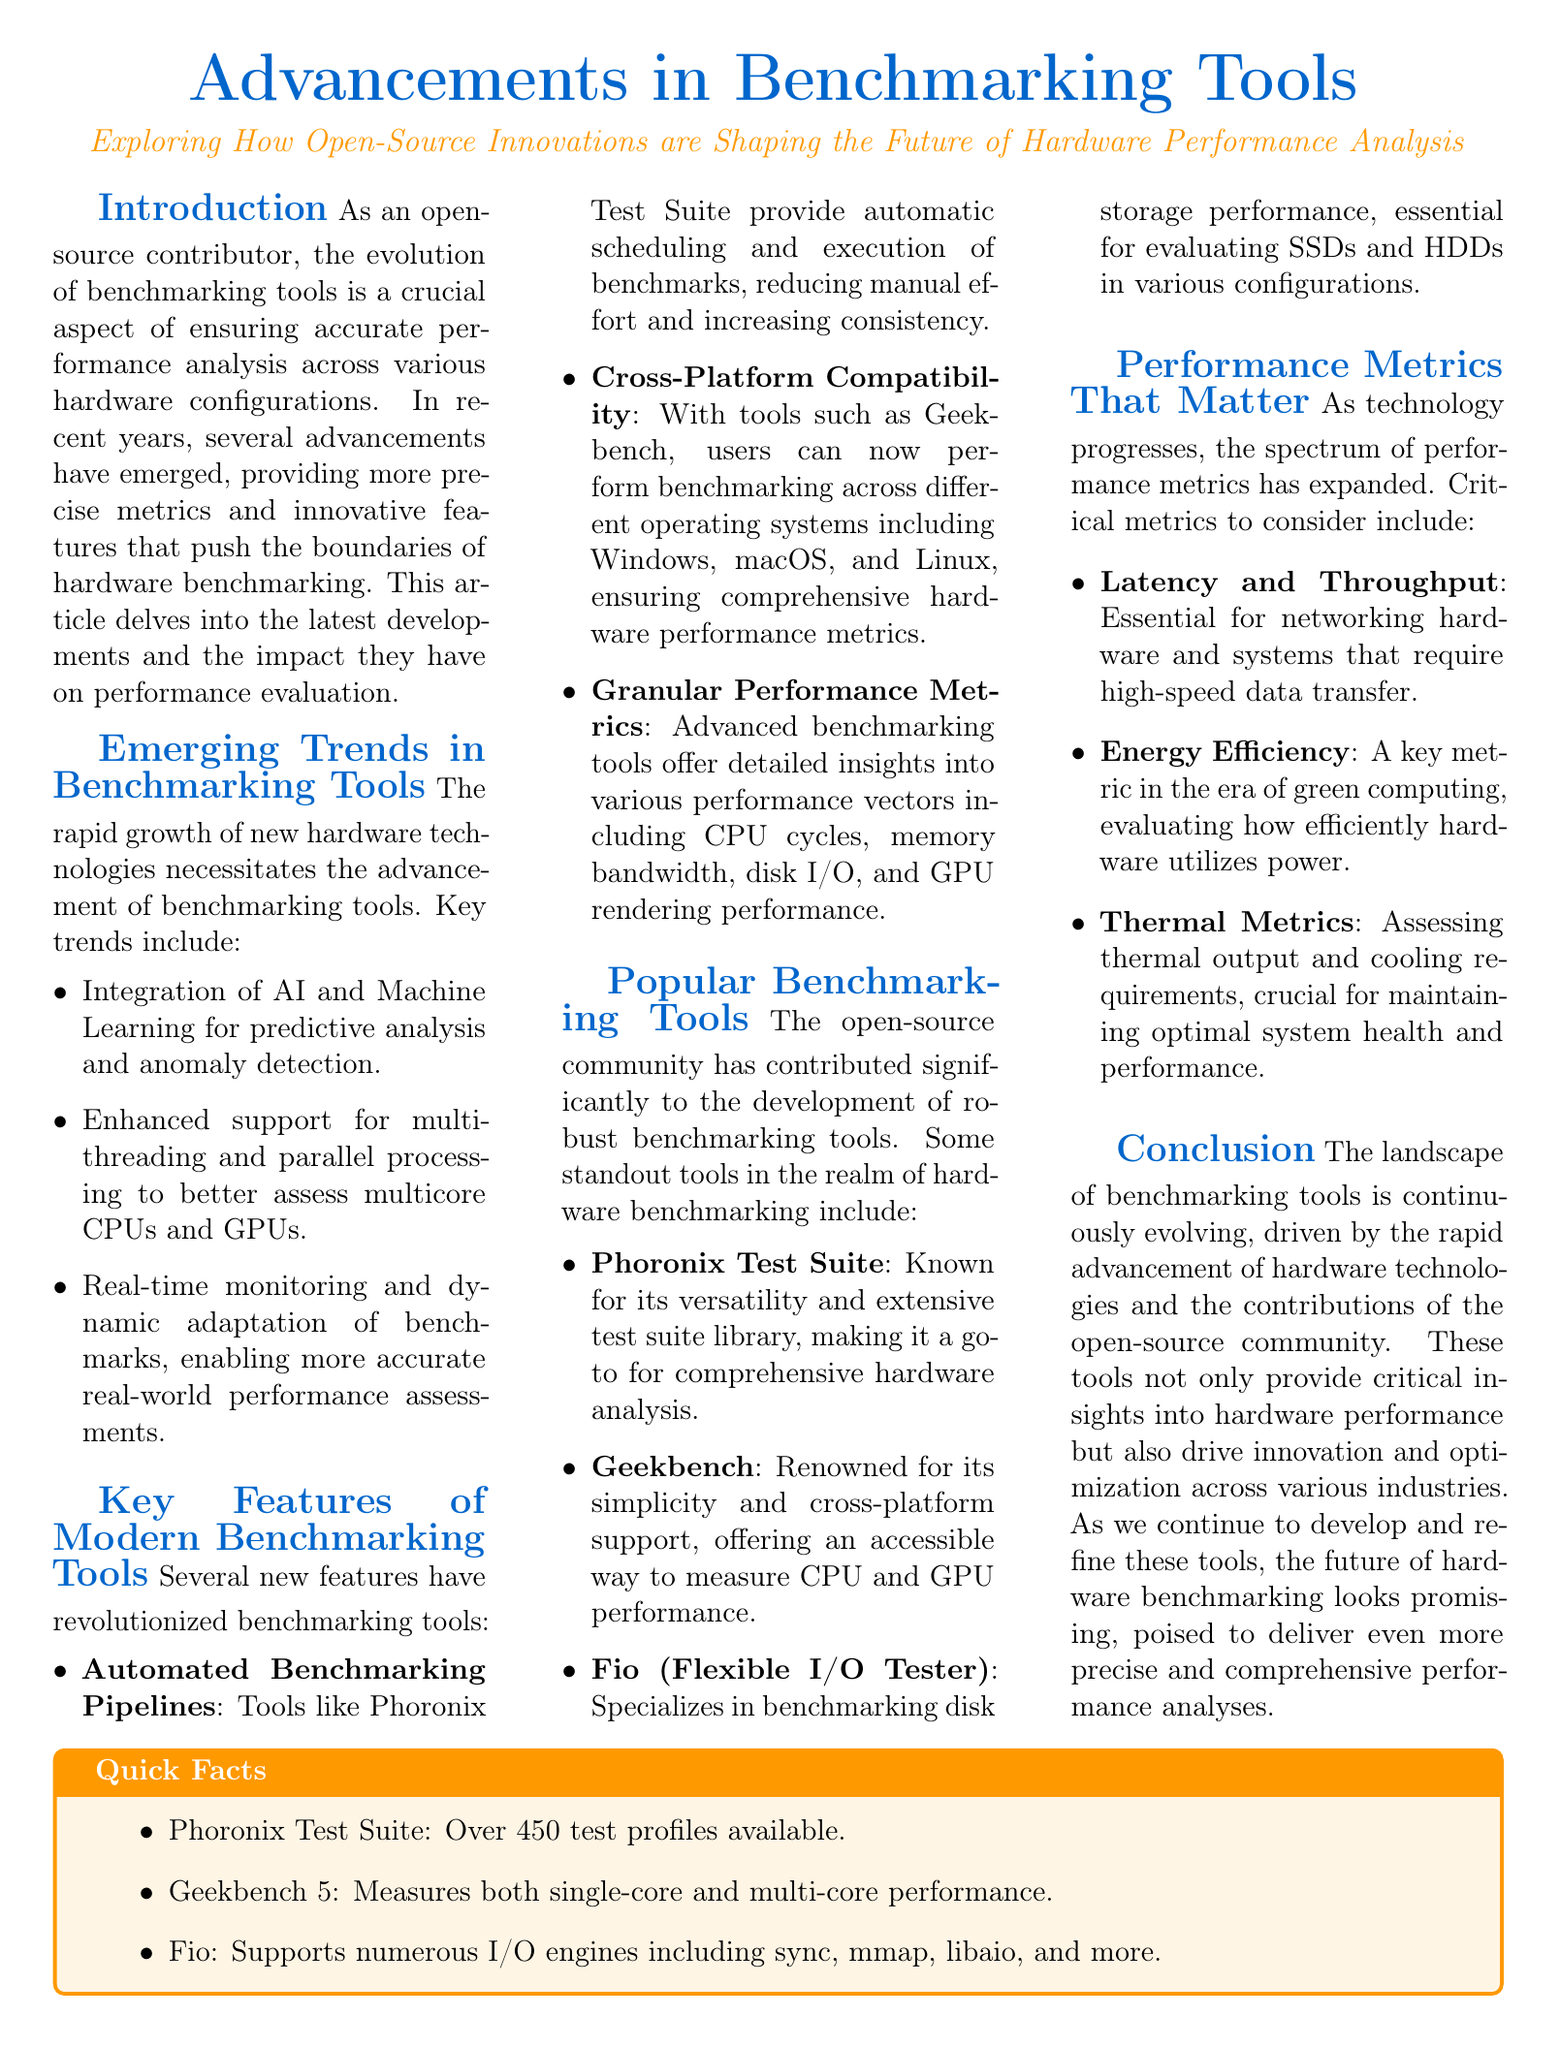What is the title of the article? The title is prominently displayed at the top of the document and indicates the primary focus of the content.
Answer: Advancements in Benchmarking Tools What type of innovations are shaping the future of hardware performance analysis? The subtitle suggests a specific focus on the impact of community contributions in the evolution of benchmarking tools.
Answer: Open-Source Innovations Name a tool known for its versatility and extensive test suite library. Within the section dedicated to popular benchmarking tools, one tool is specifically highlighted for its capabilities.
Answer: Phoronix Test Suite What metric is crucial for maintaining optimal system health? The document lists key performance metrics, one of which pertains to system performance and health.
Answer: Thermal Metrics How many test profiles are available in the Phoronix Test Suite? This detail is mentioned in the Quick Facts box, summarizing notable features of the discussed tools.
Answer: Over 450 test profiles What does Geekbench measure? The document specifically states what Geekbench evaluates within its benchmarking capabilities.
Answer: CPU and GPU performance What is a key metric in the era of green computing? An important aspect of performance evaluation in modern hardware is highlighted in the document relating to energy usage.
Answer: Energy Efficiency Which benchmarking tool specializes in disk storage performance? The document provides a specific label to one of the tools based on its specializations in performance evaluations.
Answer: Fio 